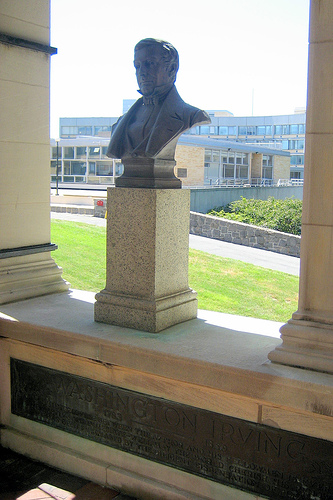<image>
Is there a shadow under the colum? Yes. The shadow is positioned underneath the colum, with the colum above it in the vertical space. 